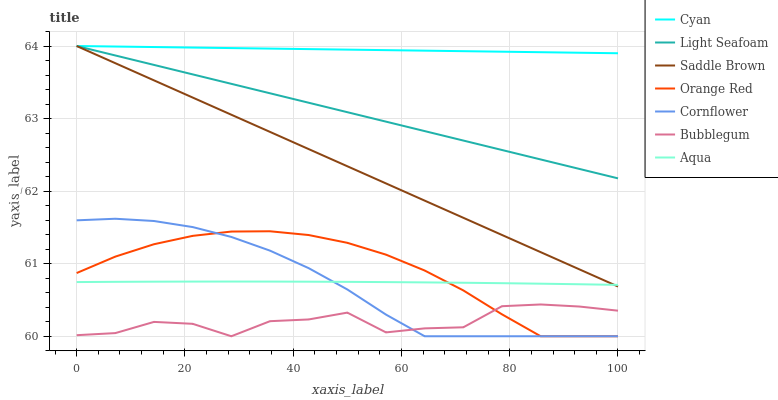Does Bubblegum have the minimum area under the curve?
Answer yes or no. Yes. Does Cyan have the maximum area under the curve?
Answer yes or no. Yes. Does Aqua have the minimum area under the curve?
Answer yes or no. No. Does Aqua have the maximum area under the curve?
Answer yes or no. No. Is Saddle Brown the smoothest?
Answer yes or no. Yes. Is Bubblegum the roughest?
Answer yes or no. Yes. Is Aqua the smoothest?
Answer yes or no. No. Is Aqua the roughest?
Answer yes or no. No. Does Aqua have the lowest value?
Answer yes or no. No. Does Aqua have the highest value?
Answer yes or no. No. Is Cornflower less than Light Seafoam?
Answer yes or no. Yes. Is Cyan greater than Bubblegum?
Answer yes or no. Yes. Does Cornflower intersect Light Seafoam?
Answer yes or no. No. 